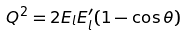Convert formula to latex. <formula><loc_0><loc_0><loc_500><loc_500>Q ^ { 2 } = 2 E _ { l } E ^ { \prime } _ { l } ( 1 - \cos \theta ) \,</formula> 